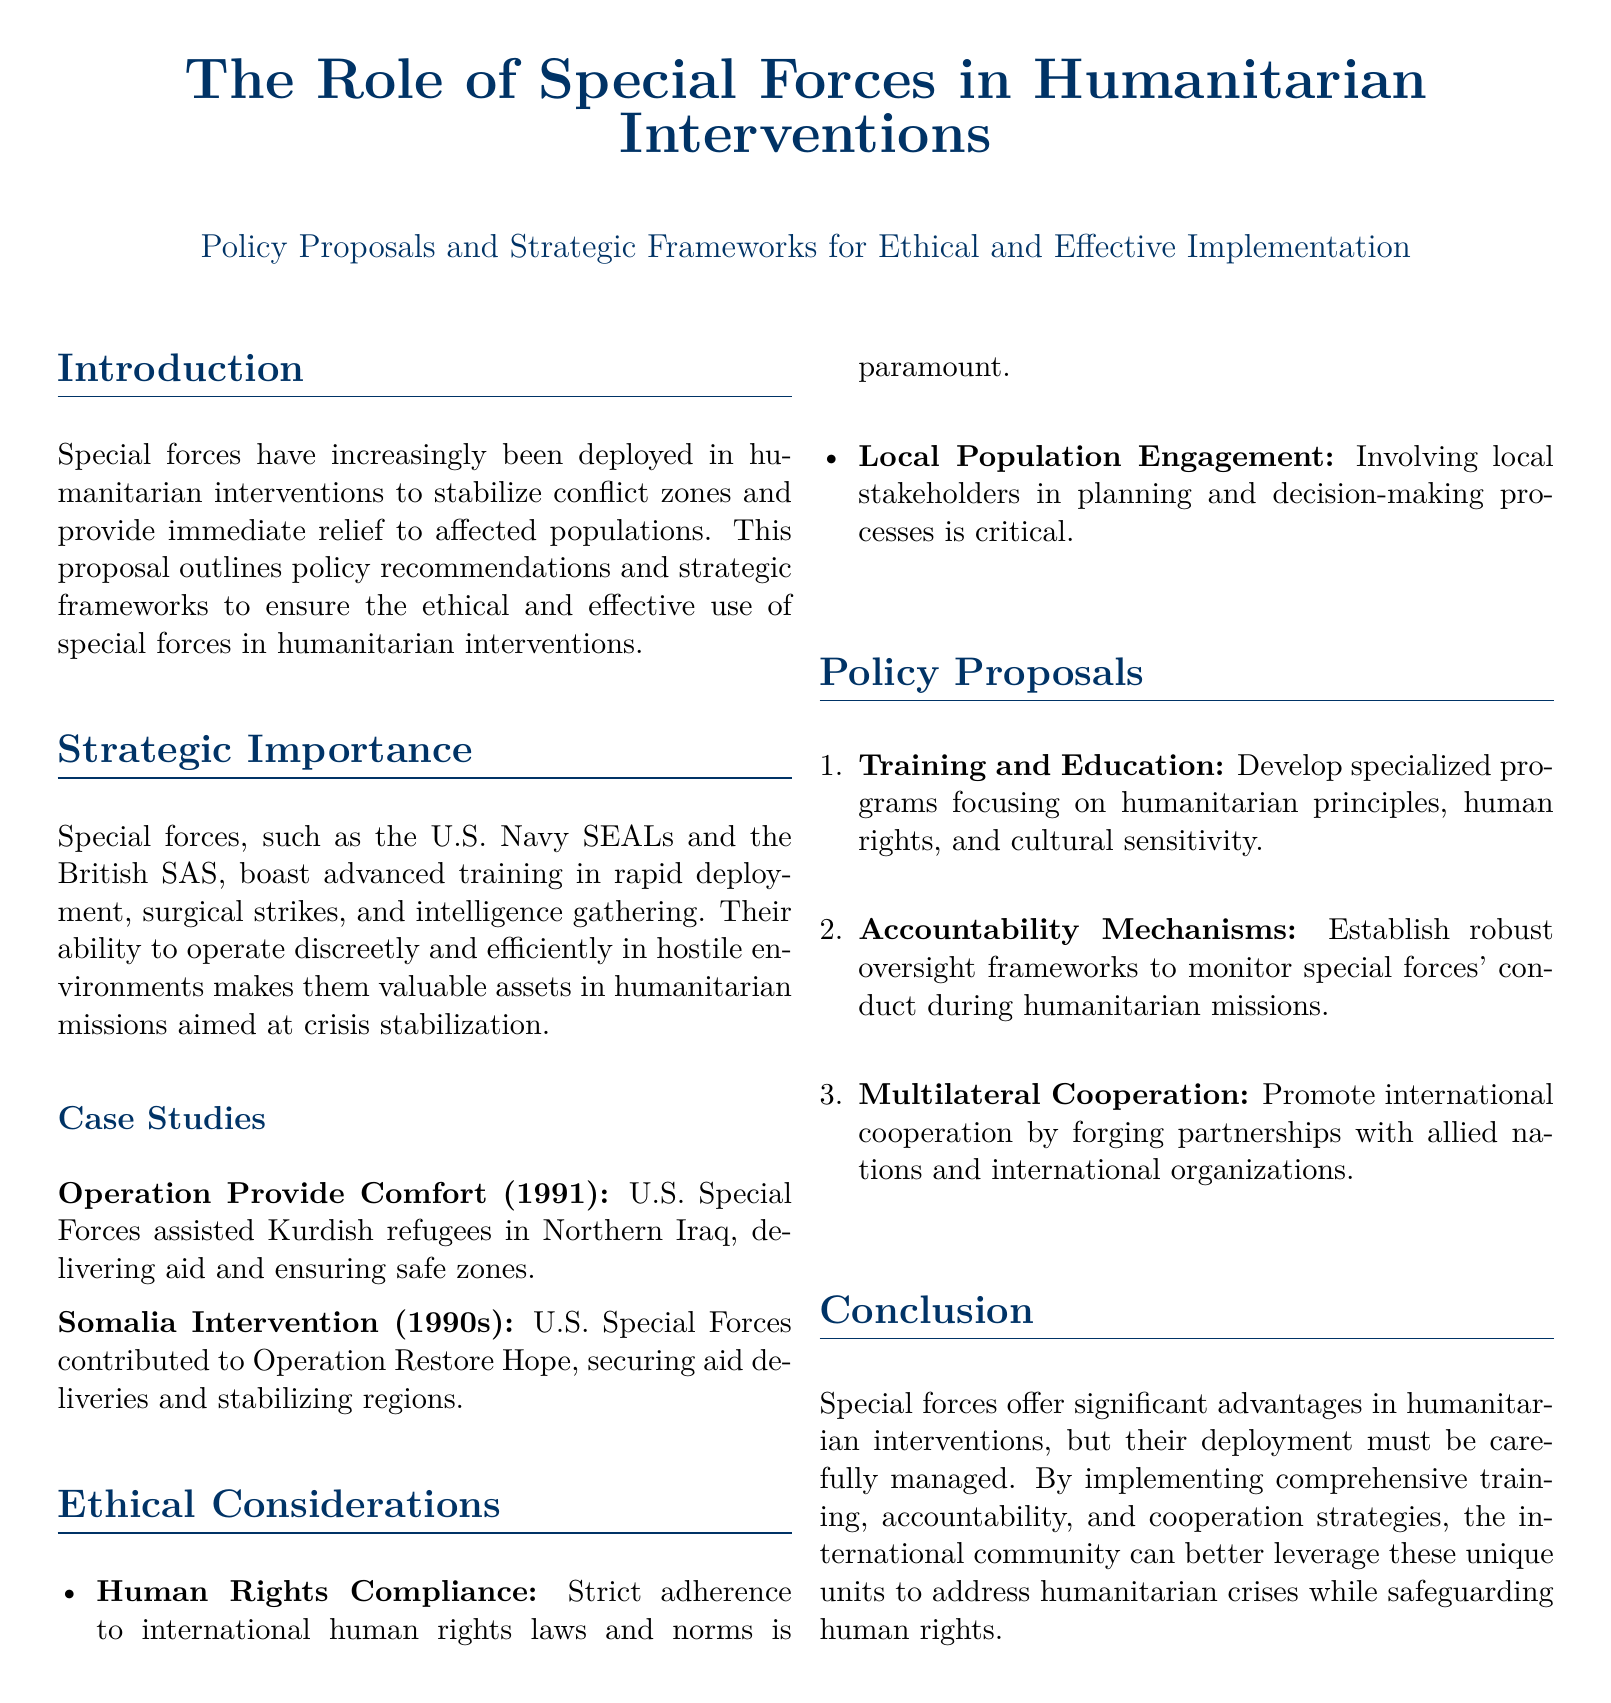What is the title of the proposal? The title is clearly stated at the beginning of the document.
Answer: The Role of Special Forces in Humanitarian Interventions What year did Operation Provide Comfort take place? The document mentions this specific operation in a case study section.
Answer: 1991 Which two special forces are highlighted in the document? The introduction discusses specific special forces and their roles in humanitarian interventions.
Answer: U.S. Navy SEALs and British SAS What is one of the ethical considerations mentioned? The document lists key ethical issues in the section dedicated to them.
Answer: Human Rights Compliance What type of training program is proposed? The document outlines a specific type of program under policy proposals.
Answer: Specialized programs focusing on humanitarian principles What is the primary focus of the conclusion? The conclusion summarizes the main points discussed throughout the proposal.
Answer: Managing deployment of special forces How many policy proposals are listed in the document? The policy proposals section contains an enumerated list.
Answer: Three What operation contributed to securing aid deliveries in Somalia? The document provides a case study that details this intervention.
Answer: Operation Restore Hope What is emphasized as a need for local engagement? The ethical considerations include aspects that require local involvement.
Answer: Local Population Engagement 